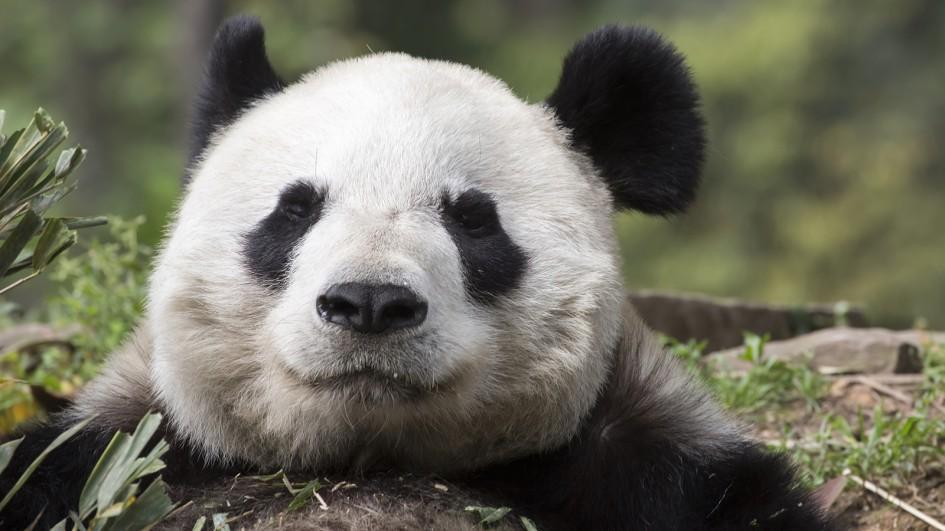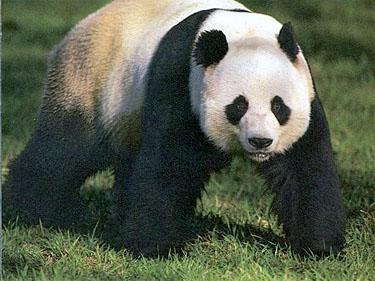The first image is the image on the left, the second image is the image on the right. Given the left and right images, does the statement "An image shows one camera-facing panda in a grassy area, standing with all four paws on a surface." hold true? Answer yes or no. Yes. The first image is the image on the left, the second image is the image on the right. For the images shown, is this caption "The panda in the image on the right has its arm around a branch." true? Answer yes or no. No. 